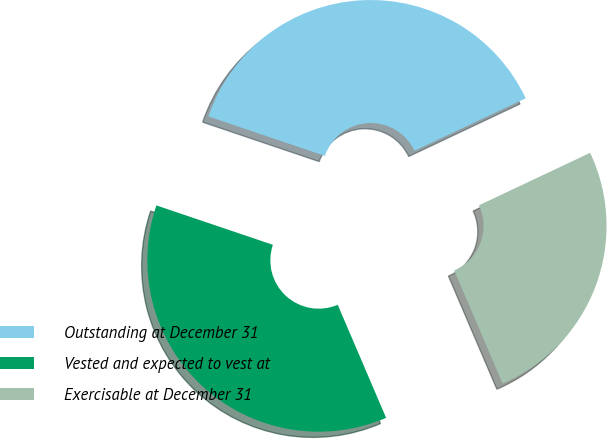Convert chart to OTSL. <chart><loc_0><loc_0><loc_500><loc_500><pie_chart><fcel>Outstanding at December 31<fcel>Vested and expected to vest at<fcel>Exercisable at December 31<nl><fcel>37.79%<fcel>36.63%<fcel>25.58%<nl></chart> 